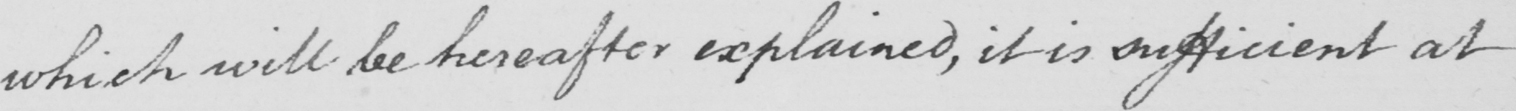Transcribe the text shown in this historical manuscript line. which will be hereafter explained , it is sufficient at 